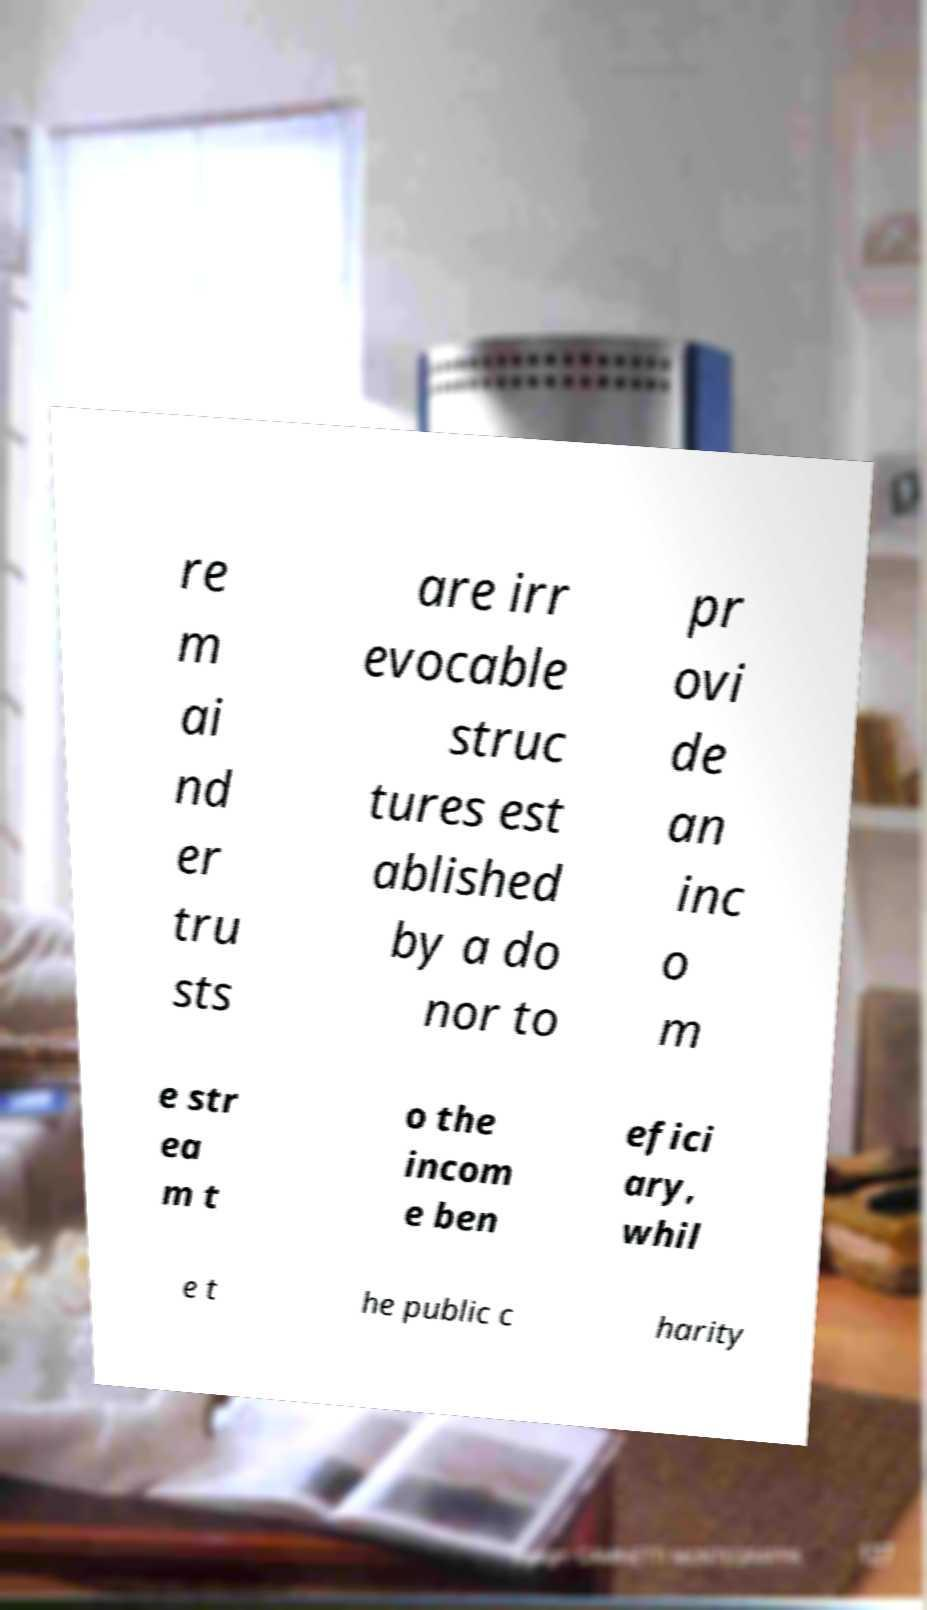There's text embedded in this image that I need extracted. Can you transcribe it verbatim? re m ai nd er tru sts are irr evocable struc tures est ablished by a do nor to pr ovi de an inc o m e str ea m t o the incom e ben efici ary, whil e t he public c harity 